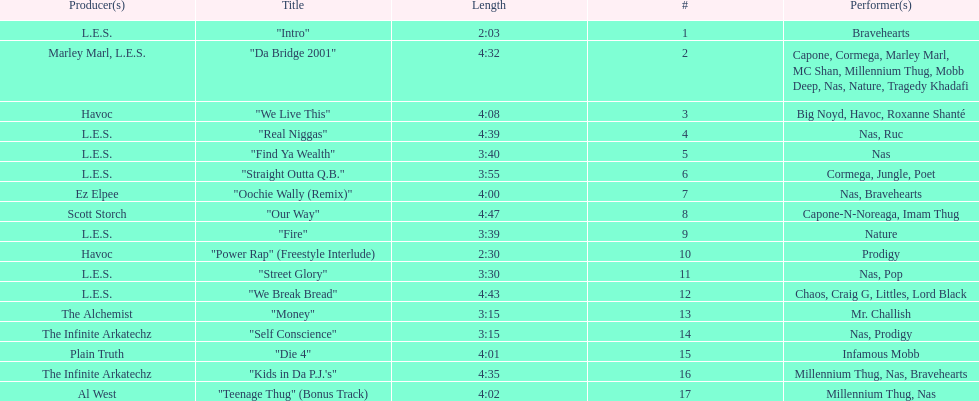Who made the last track on the album? Al West. 